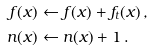Convert formula to latex. <formula><loc_0><loc_0><loc_500><loc_500>f ( x ) & \gets f ( x ) + f _ { t } ( x ) \, , \\ n ( x ) & \gets n ( x ) + 1 \, .</formula> 